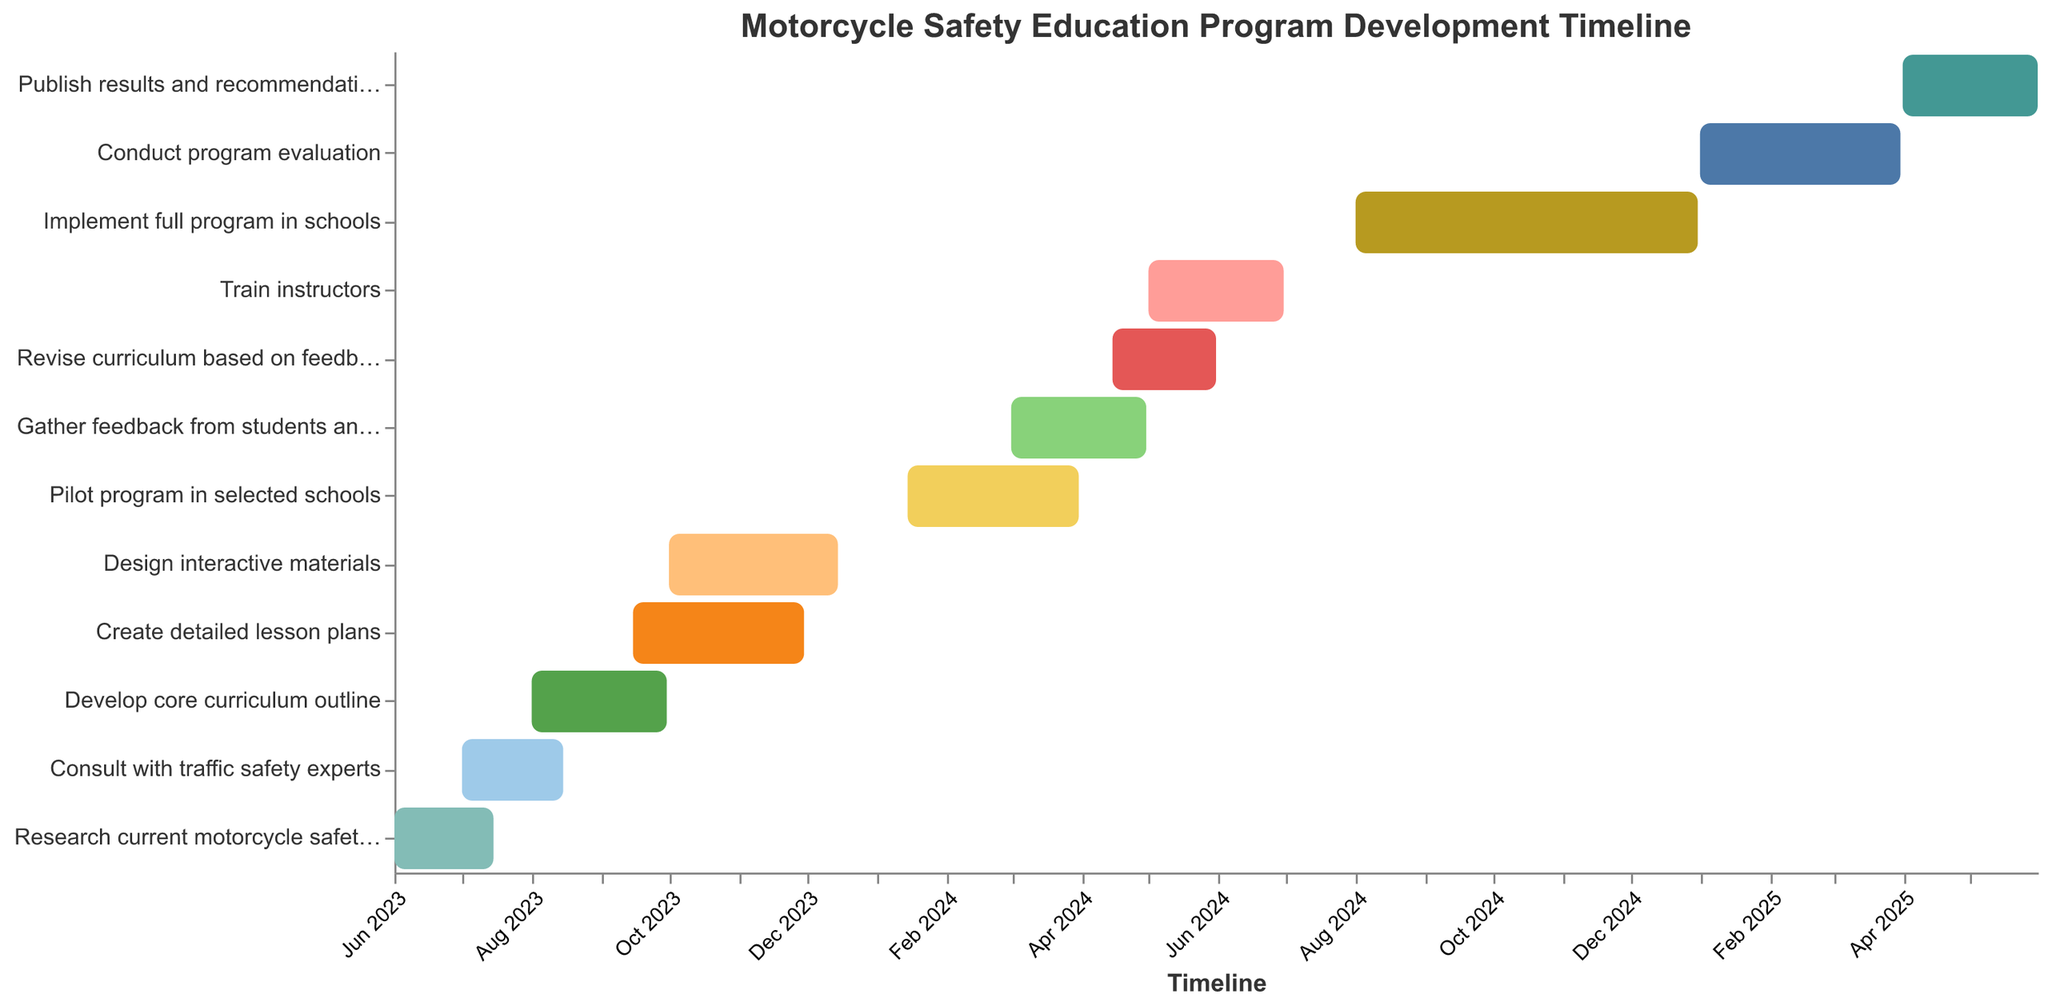What's the title of the chart? The title of the chart is situated at the top and is intended to provide an overview or summary of the chart's content. By looking at the top of the figure, you can see the written title.
Answer: Motorcycle Safety Education Program Development Timeline What is the duration of the task "Develop core curriculum outline"? To determine the duration of the task, check the start and end dates for "Develop core curriculum outline." The task starts on 2023-08-01 and ends on 2023-09-30. Subtract the start date from the end date to find the duration.
Answer: 2 months Which task lasts the longest? To find the longest task, look at the start and end dates of each task, then calculate the duration for each by subtracting the start date from the end date. Compare these durations to identify the longest one.
Answer: Implement full program in schools When does the task "Train instructors" begin and end? To answer this, find the bar labeled "Train instructors" and check its starting and ending points on the timeline.
Answer: It begins on 2024-05-01 and ends on 2024-06-30 Do any tasks overlap with "Consult with traffic safety experts"? To find overlapping tasks, look for the task "Consult with traffic safety experts" and check other tasks' timelines to see if their dates overlap with it.
Answer: Yes What tasks are performed in the year 2025? To identify tasks performed in 2025, look for bars that fall within that year's range on the timeline axis.
Answer: Conduct program evaluation, Publish results and recommendations Compare the start date of "Design interactive materials" and "Create detailed lesson plans." Which one starts first? Check the start dates of both tasks on the figure and compare them to determine which begins earlier.
Answer: Create detailed lesson plans What is the total duration from the start of the first task to the end of the last task? Identify the start date of the first task and the end date of the last task, then calculate the total duration by subtracting the earliest date from the latest date.
Answer: 2 years Which tasks occur during the same period as "Pilot program in selected schools"? To find tasks that occur during the same period, identify the timeline of "Pilot program in selected schools" and look for other bars that overlap with this period.
Answer: Gather feedback from students and teachers What feedback processes are there following the pilot program? Determine the feedback processes by identifying tasks that follow the pilot program and pertain to collecting or utilizing feedback.
Answer: Gather feedback from students and teachers, Revise curriculum based on feedback 